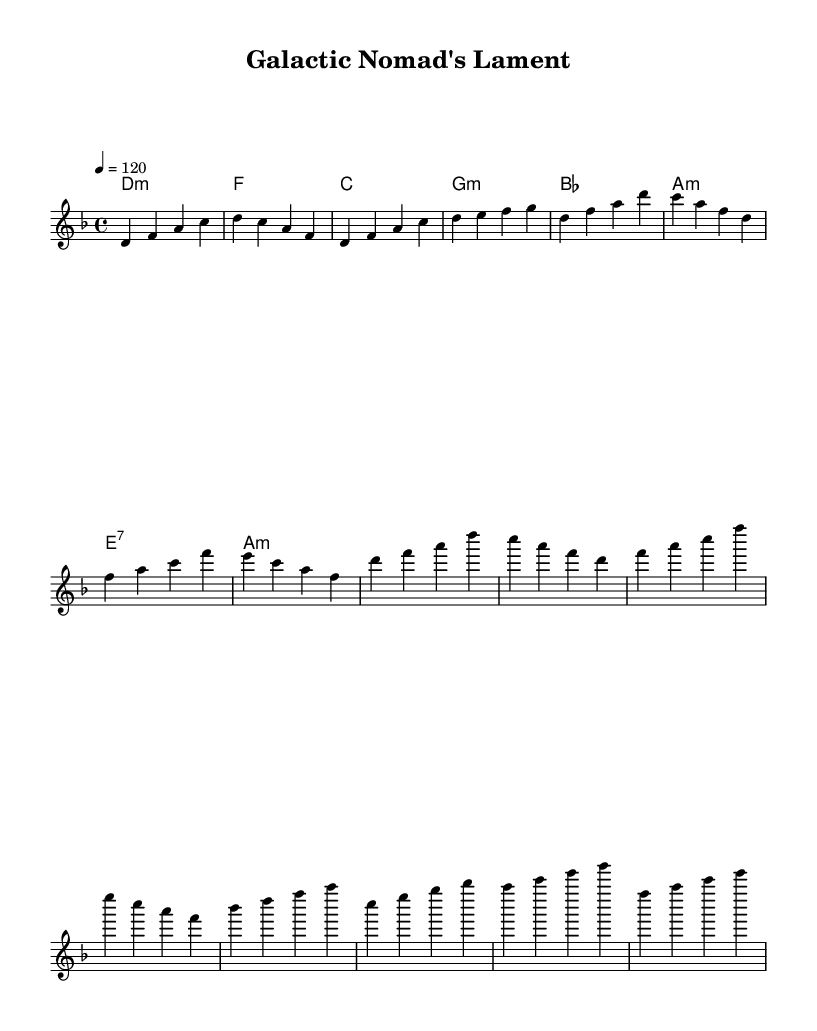What is the key signature of this music? The key signature is indicated by the number of sharps or flats at the beginning of the staff. In this case, the score is set in D minor, which has one flat (B flat).
Answer: D minor What is the time signature of this music? The time signature is shown at the beginning of the score, which indicates how many beats are in each measure. Here, the time signature is 4/4, meaning there are four beats per measure.
Answer: 4/4 What is the tempo marking for this piece? The tempo is indicated in BPM (beats per minute) within the score. The indicated tempo here is 120 BPM, which specifies how fast the piece should be played.
Answer: 120 What is the primary mode of the harmony used in this piece? The harmony in this score is defined using chord modes. The first chord listed is a D minor chord, suggesting that the primary mode used throughout the piece is minor.
Answer: minor How many sections are present in this music? The structure of the music can be observed in the different parts labeled as Intro, Verse, Chorus, and Bridge. Counting these gives a total of four distinct sections.
Answer: 4 What is the overall mood conveyed by the use of melodies and harmonies? The choice of D minor along with the patterned melodies and harmonies tends to convey a somber or melancholic mood, often referred to in music as reflective or introspective.
Answer: melancholic 